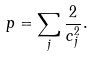Convert formula to latex. <formula><loc_0><loc_0><loc_500><loc_500>p = \sum _ { j } \frac { 2 } { c ^ { 2 } _ { j } } .</formula> 